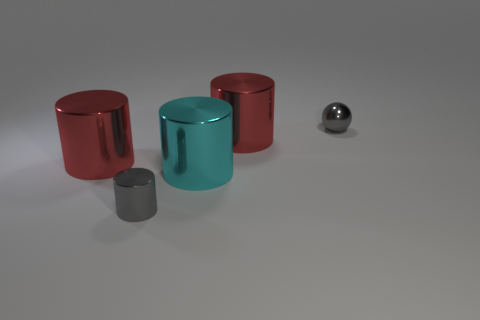Subtract all cyan cylinders. How many cylinders are left? 3 Add 5 tiny balls. How many objects exist? 10 Subtract all cyan cylinders. How many cylinders are left? 3 Subtract all balls. How many objects are left? 4 Subtract all green blocks. How many red cylinders are left? 2 Subtract 0 blue spheres. How many objects are left? 5 Subtract 1 balls. How many balls are left? 0 Subtract all cyan balls. Subtract all gray cylinders. How many balls are left? 1 Subtract all red shiny cylinders. Subtract all large metallic cylinders. How many objects are left? 0 Add 4 small cylinders. How many small cylinders are left? 5 